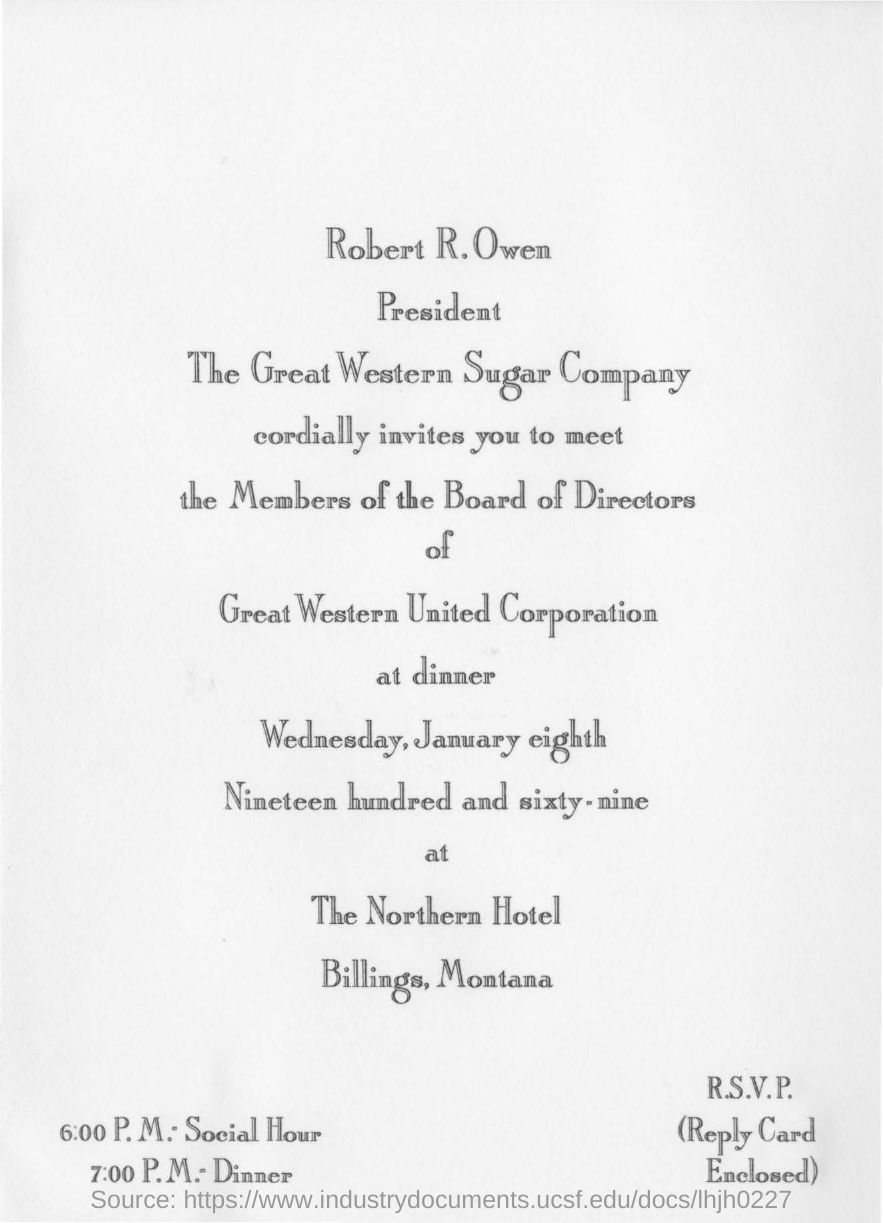Draw attention to some important aspects in this diagram. The president of The Great Western Sugar Company is Robert R. Owen. The dinner will take place on January 8th, 1969. The dinner is being held at the Northern Hotel in Billings, Montana. The sender of the invitation is Robert R. Owen. 